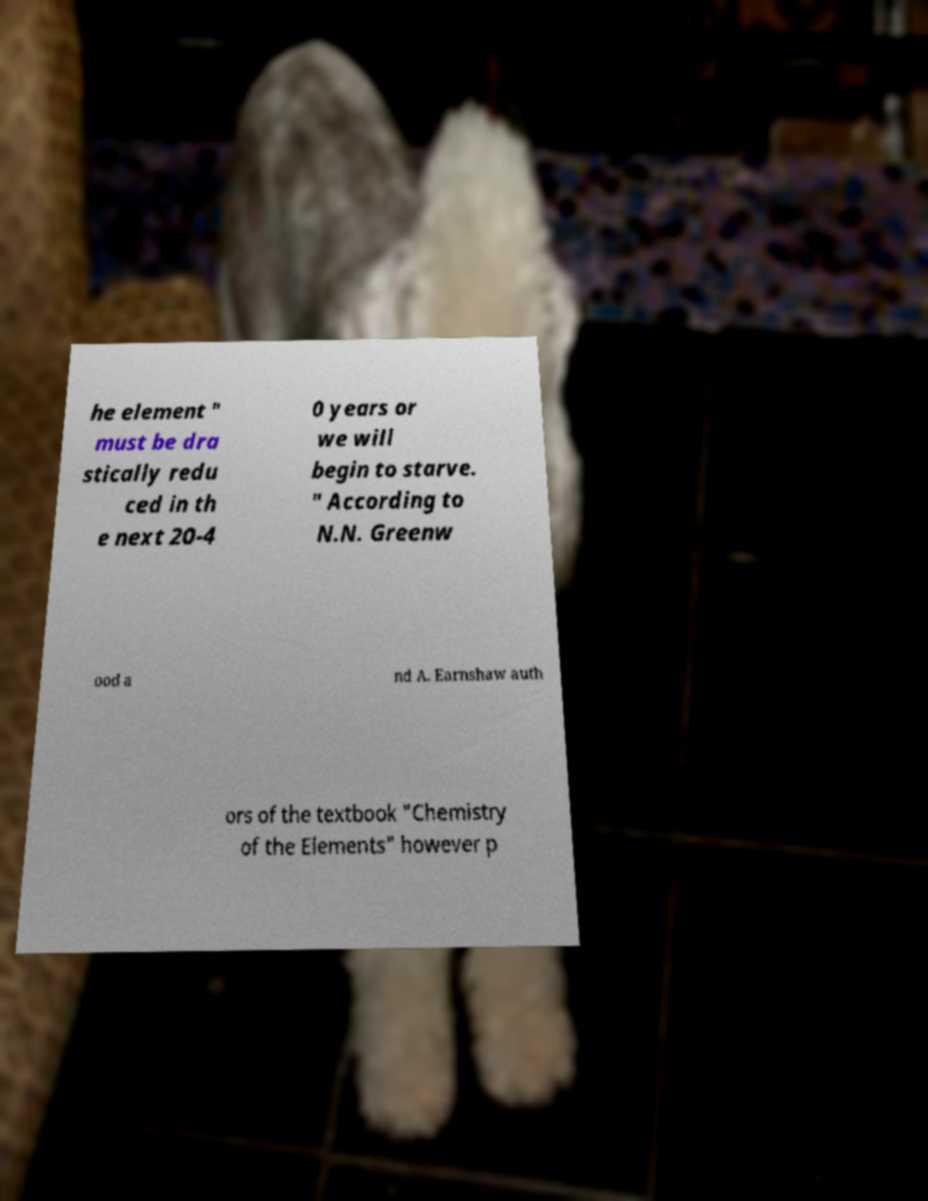What messages or text are displayed in this image? I need them in a readable, typed format. he element " must be dra stically redu ced in th e next 20-4 0 years or we will begin to starve. " According to N.N. Greenw ood a nd A. Earnshaw auth ors of the textbook "Chemistry of the Elements" however p 